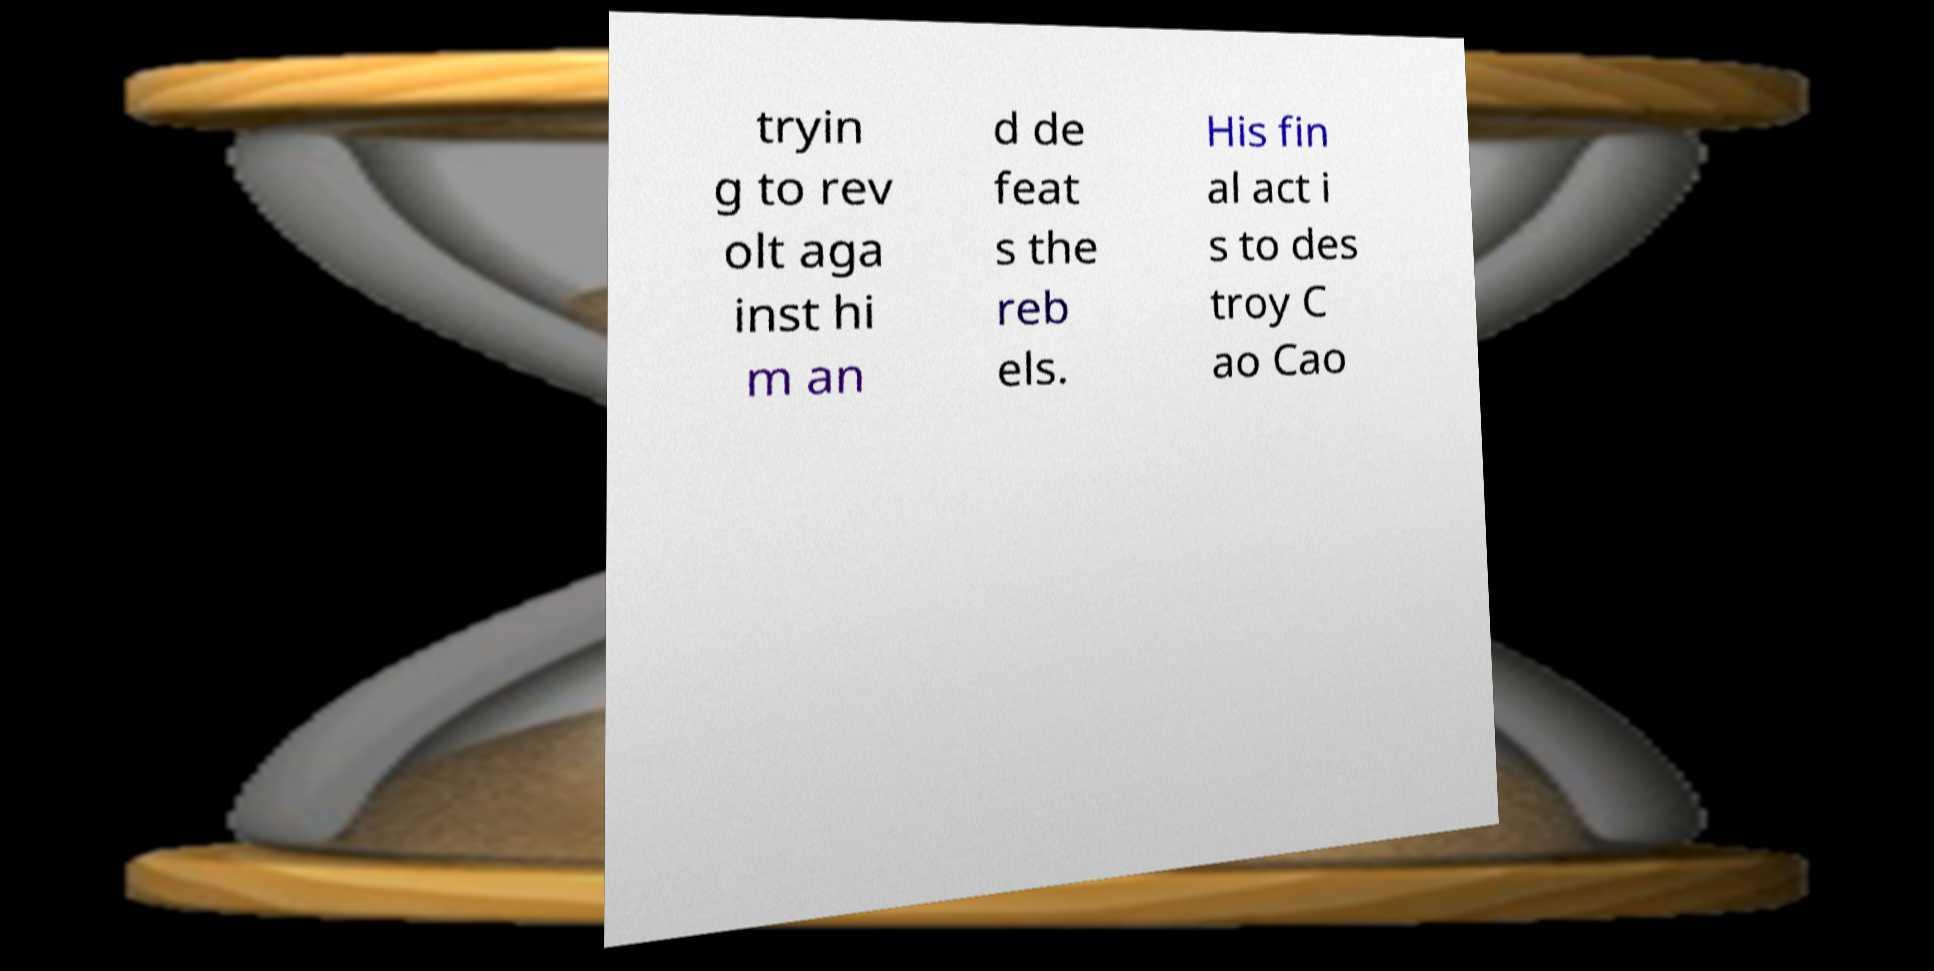Please read and relay the text visible in this image. What does it say? tryin g to rev olt aga inst hi m an d de feat s the reb els. His fin al act i s to des troy C ao Cao 